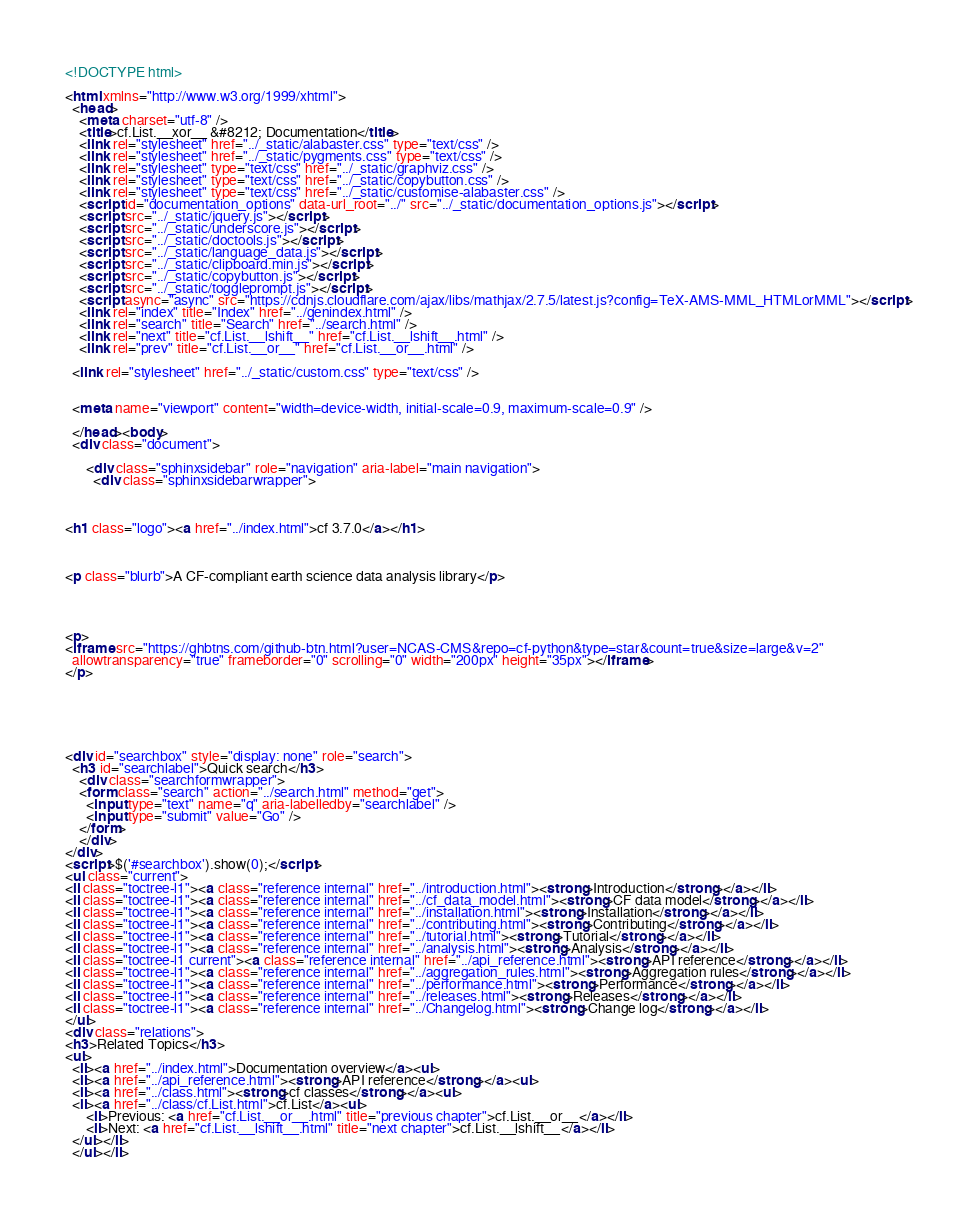<code> <loc_0><loc_0><loc_500><loc_500><_HTML_>
<!DOCTYPE html>

<html xmlns="http://www.w3.org/1999/xhtml">
  <head>
    <meta charset="utf-8" />
    <title>cf.List.__xor__ &#8212; Documentation</title>
    <link rel="stylesheet" href="../_static/alabaster.css" type="text/css" />
    <link rel="stylesheet" href="../_static/pygments.css" type="text/css" />
    <link rel="stylesheet" type="text/css" href="../_static/graphviz.css" />
    <link rel="stylesheet" type="text/css" href="../_static/copybutton.css" />
    <link rel="stylesheet" type="text/css" href="../_static/customise-alabaster.css" />
    <script id="documentation_options" data-url_root="../" src="../_static/documentation_options.js"></script>
    <script src="../_static/jquery.js"></script>
    <script src="../_static/underscore.js"></script>
    <script src="../_static/doctools.js"></script>
    <script src="../_static/language_data.js"></script>
    <script src="../_static/clipboard.min.js"></script>
    <script src="../_static/copybutton.js"></script>
    <script src="../_static/toggleprompt.js"></script>
    <script async="async" src="https://cdnjs.cloudflare.com/ajax/libs/mathjax/2.7.5/latest.js?config=TeX-AMS-MML_HTMLorMML"></script>
    <link rel="index" title="Index" href="../genindex.html" />
    <link rel="search" title="Search" href="../search.html" />
    <link rel="next" title="cf.List.__lshift__" href="cf.List.__lshift__.html" />
    <link rel="prev" title="cf.List.__or__" href="cf.List.__or__.html" />
   
  <link rel="stylesheet" href="../_static/custom.css" type="text/css" />
  
  
  <meta name="viewport" content="width=device-width, initial-scale=0.9, maximum-scale=0.9" />

  </head><body>
  <div class="document">
    
      <div class="sphinxsidebar" role="navigation" aria-label="main navigation">
        <div class="sphinxsidebarwrapper">



<h1 class="logo"><a href="../index.html">cf 3.7.0</a></h1>



<p class="blurb">A CF-compliant earth science data analysis library</p>




<p>
<iframe src="https://ghbtns.com/github-btn.html?user=NCAS-CMS&repo=cf-python&type=star&count=true&size=large&v=2"
  allowtransparency="true" frameborder="0" scrolling="0" width="200px" height="35px"></iframe>
</p>






<div id="searchbox" style="display: none" role="search">
  <h3 id="searchlabel">Quick search</h3>
    <div class="searchformwrapper">
    <form class="search" action="../search.html" method="get">
      <input type="text" name="q" aria-labelledby="searchlabel" />
      <input type="submit" value="Go" />
    </form>
    </div>
</div>
<script>$('#searchbox').show(0);</script>
<ul class="current">
<li class="toctree-l1"><a class="reference internal" href="../introduction.html"><strong>Introduction</strong></a></li>
<li class="toctree-l1"><a class="reference internal" href="../cf_data_model.html"><strong>CF data model</strong></a></li>
<li class="toctree-l1"><a class="reference internal" href="../installation.html"><strong>Installation</strong></a></li>
<li class="toctree-l1"><a class="reference internal" href="../contributing.html"><strong>Contributing</strong></a></li>
<li class="toctree-l1"><a class="reference internal" href="../tutorial.html"><strong>Tutorial</strong></a></li>
<li class="toctree-l1"><a class="reference internal" href="../analysis.html"><strong>Analysis</strong></a></li>
<li class="toctree-l1 current"><a class="reference internal" href="../api_reference.html"><strong>API reference</strong></a></li>
<li class="toctree-l1"><a class="reference internal" href="../aggregation_rules.html"><strong>Aggregation rules</strong></a></li>
<li class="toctree-l1"><a class="reference internal" href="../performance.html"><strong>Performance</strong></a></li>
<li class="toctree-l1"><a class="reference internal" href="../releases.html"><strong>Releases</strong></a></li>
<li class="toctree-l1"><a class="reference internal" href="../Changelog.html"><strong>Change log</strong></a></li>
</ul>
<div class="relations">
<h3>Related Topics</h3>
<ul>
  <li><a href="../index.html">Documentation overview</a><ul>
  <li><a href="../api_reference.html"><strong>API reference</strong></a><ul>
  <li><a href="../class.html"><strong>cf classes</strong></a><ul>
  <li><a href="../class/cf.List.html">cf.List</a><ul>
      <li>Previous: <a href="cf.List.__or__.html" title="previous chapter">cf.List.__or__</a></li>
      <li>Next: <a href="cf.List.__lshift__.html" title="next chapter">cf.List.__lshift__</a></li>
  </ul></li>
  </ul></li></code> 